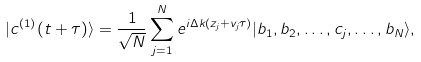Convert formula to latex. <formula><loc_0><loc_0><loc_500><loc_500>| c ^ { ( 1 ) } ( t + \tau ) \rangle = \frac { 1 } { \sqrt { N } } \sum _ { j = 1 } ^ { N } e ^ { i \Delta k ( z _ { j } + v _ { j } \tau ) } | b _ { 1 } , b _ { 2 } , \dots , c _ { j } , \dots , b _ { N } \rangle ,</formula> 